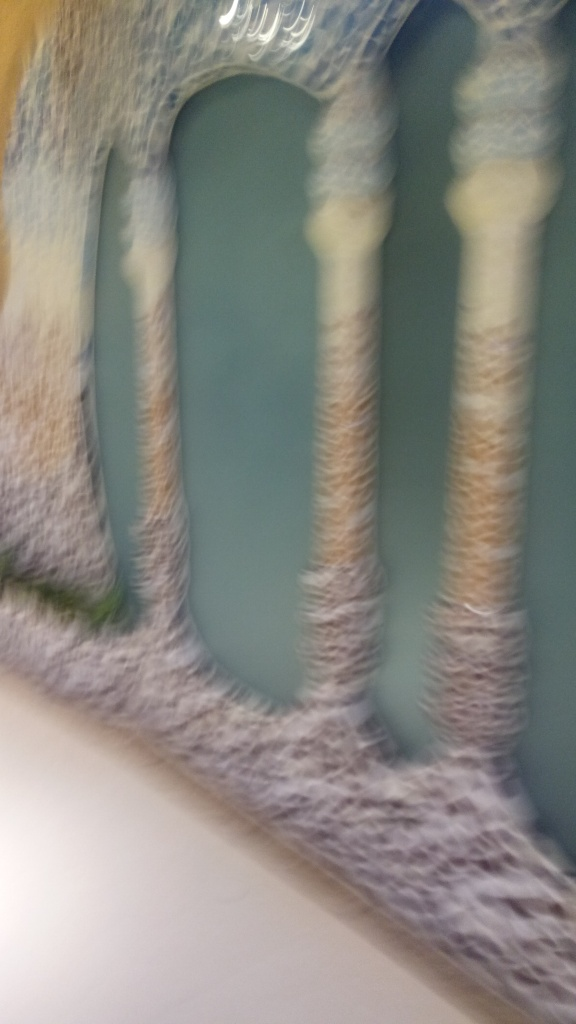Is the image of high quality? The assessment that the image is not of high quality is correct, as it appears to be blurry and lacks clarity. Details within the image are not sharp, and the color balance seems off, which suggests that the picture might have been taken quickly or in motion without proper focus or stabilization. 